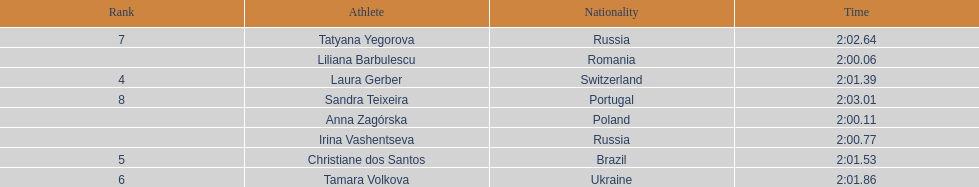The last runner crossed the finish line in 2:03.01. what was the previous time for the 7th runner? 2:02.64. 